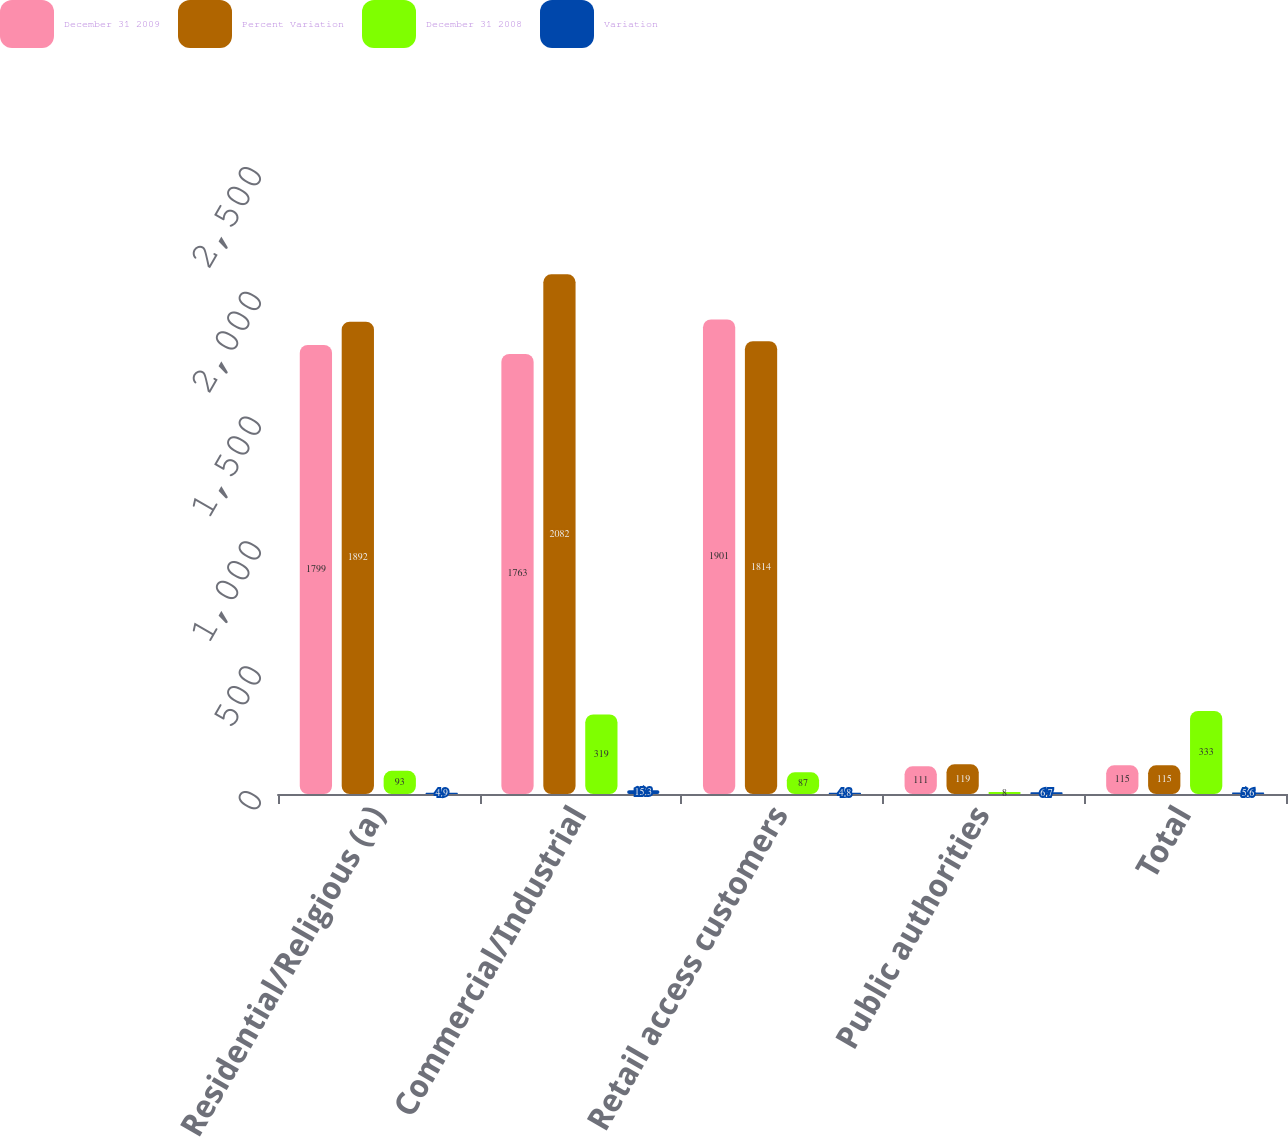<chart> <loc_0><loc_0><loc_500><loc_500><stacked_bar_chart><ecel><fcel>Residential/Religious (a)<fcel>Commercial/Industrial<fcel>Retail access customers<fcel>Public authorities<fcel>Total<nl><fcel>December 31 2009<fcel>1799<fcel>1763<fcel>1901<fcel>111<fcel>115<nl><fcel>Percent Variation<fcel>1892<fcel>2082<fcel>1814<fcel>119<fcel>115<nl><fcel>December 31 2008<fcel>93<fcel>319<fcel>87<fcel>8<fcel>333<nl><fcel>Variation<fcel>4.9<fcel>15.3<fcel>4.8<fcel>6.7<fcel>5.6<nl></chart> 